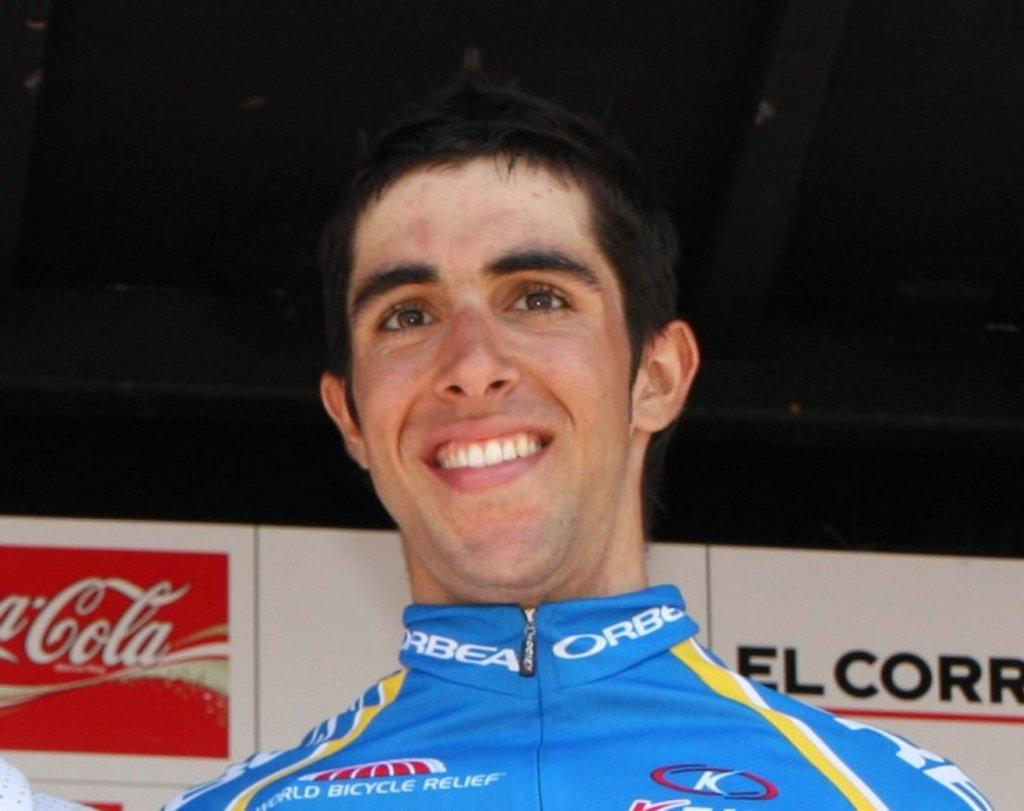<image>
Present a compact description of the photo's key features. A cyclist smiles wearing a blue top with world bicycle relief on it stands in front of a coca cola advertising boardd 